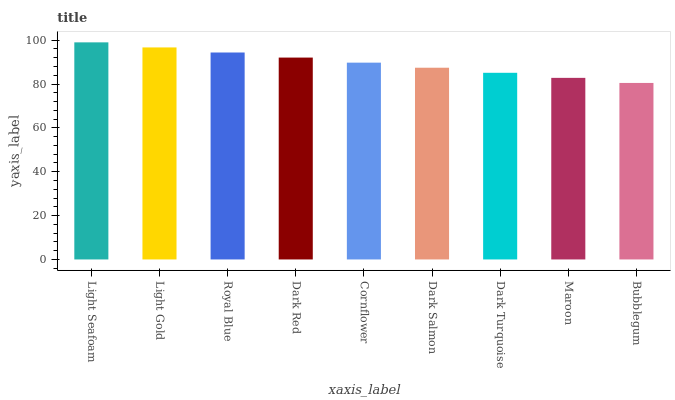Is Light Gold the minimum?
Answer yes or no. No. Is Light Gold the maximum?
Answer yes or no. No. Is Light Seafoam greater than Light Gold?
Answer yes or no. Yes. Is Light Gold less than Light Seafoam?
Answer yes or no. Yes. Is Light Gold greater than Light Seafoam?
Answer yes or no. No. Is Light Seafoam less than Light Gold?
Answer yes or no. No. Is Cornflower the high median?
Answer yes or no. Yes. Is Cornflower the low median?
Answer yes or no. Yes. Is Light Seafoam the high median?
Answer yes or no. No. Is Dark Salmon the low median?
Answer yes or no. No. 